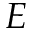Convert formula to latex. <formula><loc_0><loc_0><loc_500><loc_500>E</formula> 